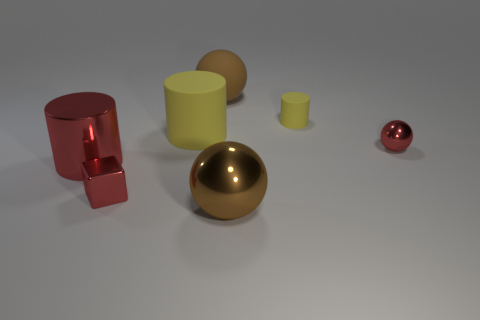Are there fewer brown objects that are to the left of the large brown rubber object than shiny objects?
Offer a very short reply. Yes. Is the shape of the tiny yellow thing the same as the large brown matte thing?
Give a very brief answer. No. How many shiny things are either cyan cylinders or small balls?
Ensure brevity in your answer.  1. Are there any gray metal spheres that have the same size as the red metallic cube?
Your response must be concise. No. There is a thing that is the same color as the large rubber ball; what shape is it?
Provide a succinct answer. Sphere. What number of red cylinders are the same size as the brown metal thing?
Provide a succinct answer. 1. There is a sphere in front of the red ball; is it the same size as the red thing to the left of the small red cube?
Provide a short and direct response. Yes. What number of objects are large brown balls or small red metal things that are right of the small yellow matte cylinder?
Ensure brevity in your answer.  3. The big metallic ball has what color?
Your answer should be compact. Brown. There is a yellow object on the left side of the large brown sphere that is behind the matte cylinder that is to the left of the matte sphere; what is it made of?
Make the answer very short. Rubber. 